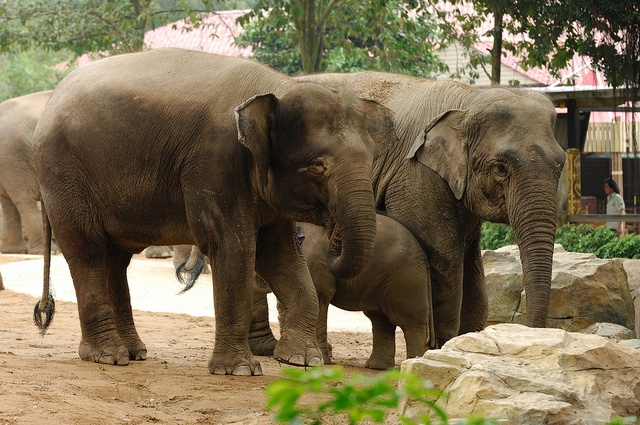Describe the objects in this image and their specific colors. I can see elephant in darkgray, black, maroon, and gray tones, elephant in darkgray, black, and gray tones, elephant in darkgray, black, and gray tones, elephant in darkgray, gray, and tan tones, and people in darkgray, gray, and black tones in this image. 